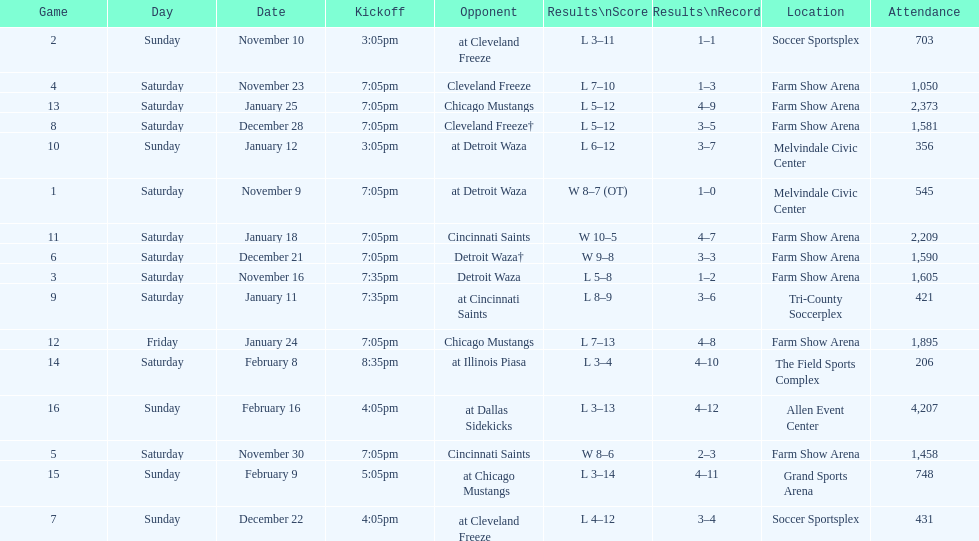Which opponent is listed first in the table? Detroit Waza. 